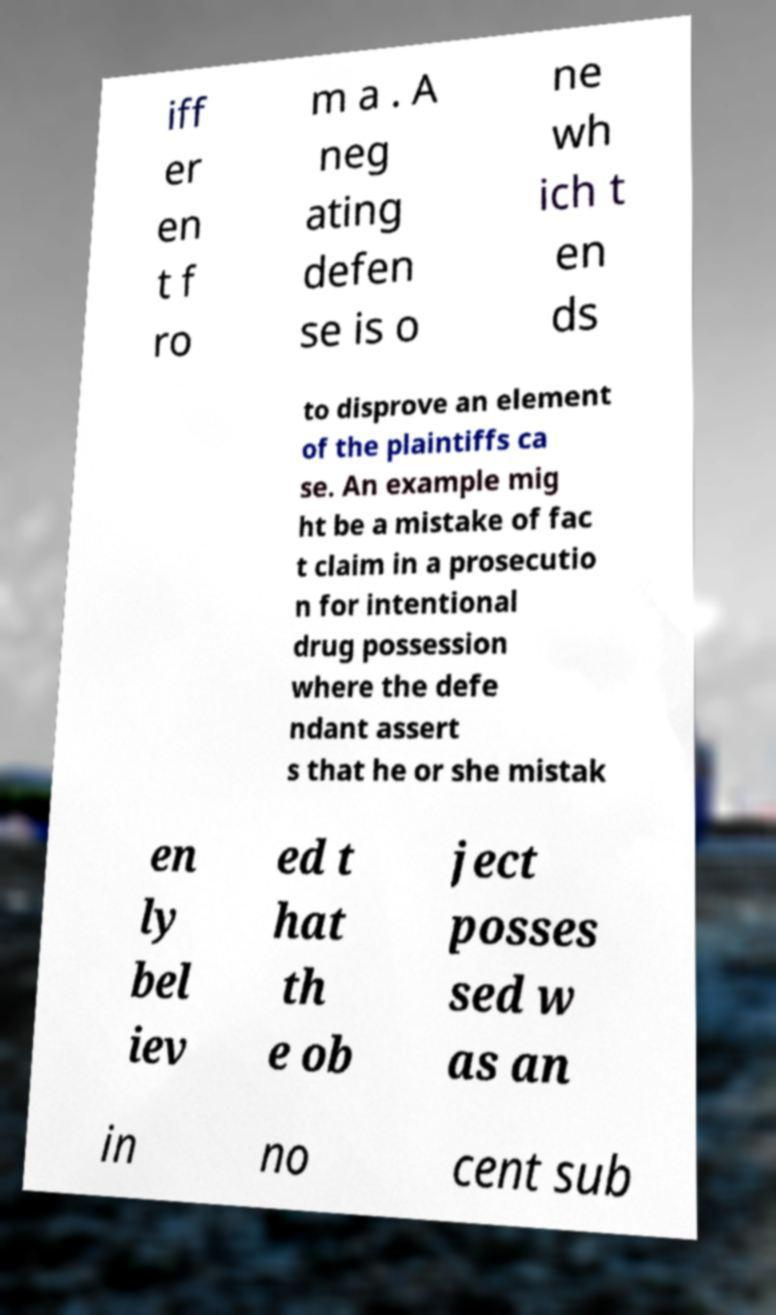I need the written content from this picture converted into text. Can you do that? iff er en t f ro m a . A neg ating defen se is o ne wh ich t en ds to disprove an element of the plaintiffs ca se. An example mig ht be a mistake of fac t claim in a prosecutio n for intentional drug possession where the defe ndant assert s that he or she mistak en ly bel iev ed t hat th e ob ject posses sed w as an in no cent sub 